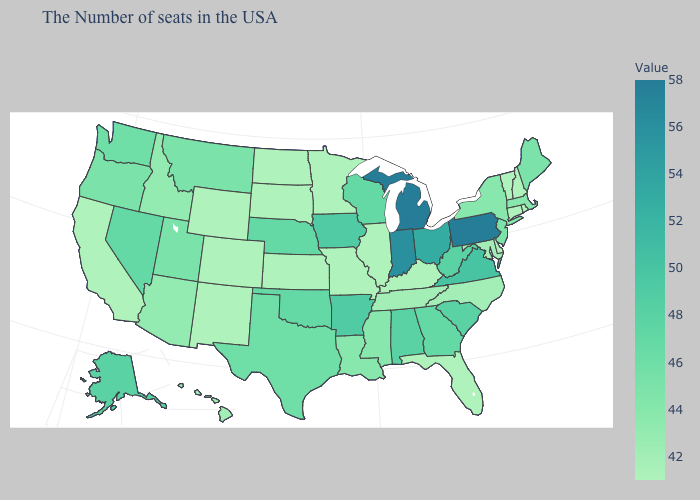Which states have the highest value in the USA?
Short answer required. Pennsylvania, Michigan. Does Michigan have a lower value than Nevada?
Short answer required. No. Does Florida have a lower value than Arkansas?
Write a very short answer. Yes. Does Illinois have the highest value in the USA?
Answer briefly. No. Which states have the lowest value in the USA?
Concise answer only. Rhode Island, New Hampshire, Vermont, Connecticut, Delaware, Florida, Kentucky, Illinois, Missouri, Minnesota, Kansas, South Dakota, North Dakota, Wyoming, Colorado, New Mexico, California. Does Idaho have a higher value than Rhode Island?
Concise answer only. Yes. Does Florida have a higher value than Utah?
Write a very short answer. No. Does New York have a higher value than Nevada?
Write a very short answer. No. Does the map have missing data?
Keep it brief. No. 